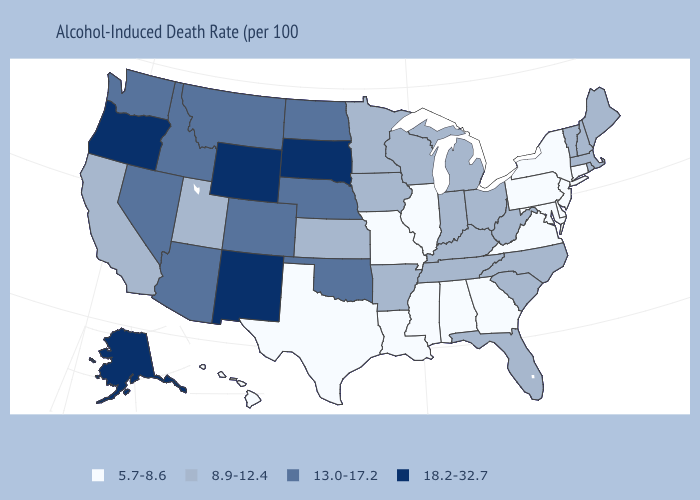Name the states that have a value in the range 5.7-8.6?
Be succinct. Alabama, Connecticut, Delaware, Georgia, Hawaii, Illinois, Louisiana, Maryland, Mississippi, Missouri, New Jersey, New York, Pennsylvania, Texas, Virginia. Does Idaho have a lower value than Vermont?
Answer briefly. No. Which states have the highest value in the USA?
Give a very brief answer. Alaska, New Mexico, Oregon, South Dakota, Wyoming. What is the highest value in the MidWest ?
Keep it brief. 18.2-32.7. Name the states that have a value in the range 18.2-32.7?
Be succinct. Alaska, New Mexico, Oregon, South Dakota, Wyoming. Name the states that have a value in the range 5.7-8.6?
Write a very short answer. Alabama, Connecticut, Delaware, Georgia, Hawaii, Illinois, Louisiana, Maryland, Mississippi, Missouri, New Jersey, New York, Pennsylvania, Texas, Virginia. What is the value of Utah?
Be succinct. 8.9-12.4. Does the map have missing data?
Give a very brief answer. No. Does Kentucky have a lower value than Wyoming?
Be succinct. Yes. What is the lowest value in states that border Minnesota?
Quick response, please. 8.9-12.4. Name the states that have a value in the range 13.0-17.2?
Give a very brief answer. Arizona, Colorado, Idaho, Montana, Nebraska, Nevada, North Dakota, Oklahoma, Washington. Name the states that have a value in the range 8.9-12.4?
Write a very short answer. Arkansas, California, Florida, Indiana, Iowa, Kansas, Kentucky, Maine, Massachusetts, Michigan, Minnesota, New Hampshire, North Carolina, Ohio, Rhode Island, South Carolina, Tennessee, Utah, Vermont, West Virginia, Wisconsin. What is the highest value in states that border New Mexico?
Short answer required. 13.0-17.2. Which states have the highest value in the USA?
Give a very brief answer. Alaska, New Mexico, Oregon, South Dakota, Wyoming. What is the lowest value in the MidWest?
Answer briefly. 5.7-8.6. 